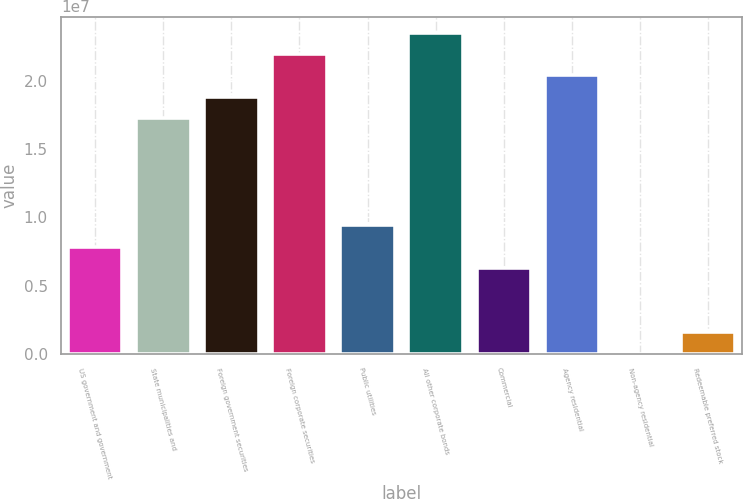Convert chart. <chart><loc_0><loc_0><loc_500><loc_500><bar_chart><fcel>US government and government<fcel>State municipalities and<fcel>Foreign government securities<fcel>Foreign corporate securities<fcel>Public utilities<fcel>All other corporate bonds<fcel>Commercial<fcel>Agency residential<fcel>Non-agency residential<fcel>Redeemable preferred stock<nl><fcel>7.85006e+06<fcel>1.72609e+07<fcel>1.88294e+07<fcel>2.19664e+07<fcel>9.41854e+06<fcel>2.35349e+07<fcel>6.28158e+06<fcel>2.03979e+07<fcel>7660<fcel>1.57614e+06<nl></chart> 